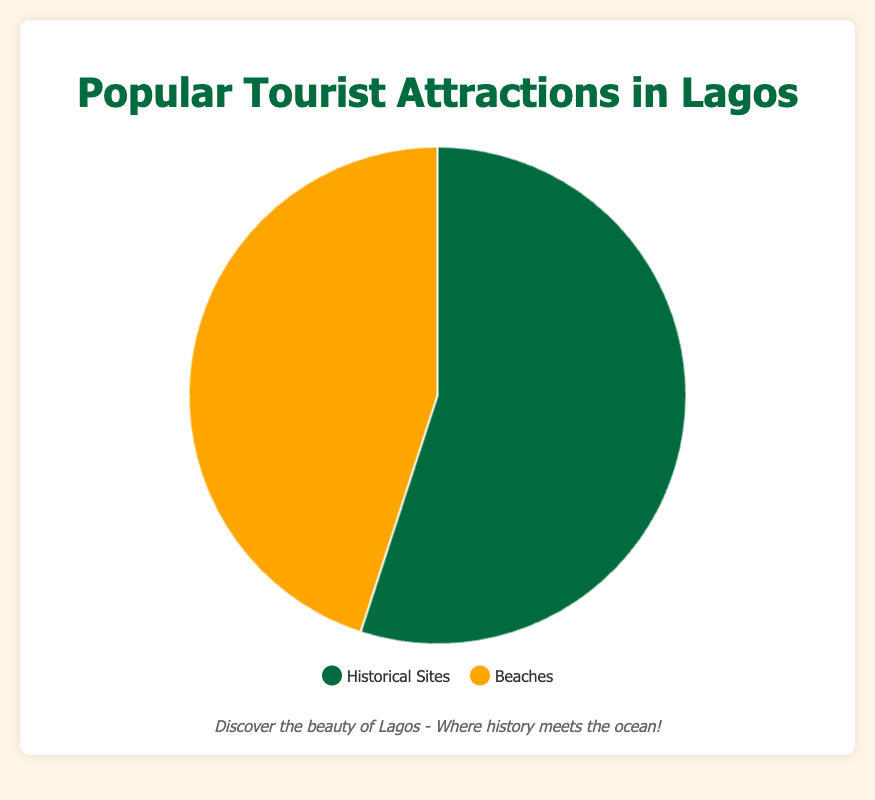What percentage of tourist attractions in Lagos are historical sites? The figure shows that historical sites make up 55% of the tourist attractions.
Answer: 55% What is the difference in percentage points between historical sites and beaches? Historical sites are at 55% and beaches at 45%, so the difference is 55 - 45 = 10 percentage points.
Answer: 10 If 20 more tourist attractions were historical sites, making the total attractions 200, what would be the new percentage of historical sites? Initially, 55% of 100 attractions are historical sites, so with 20 more, the total is 75 historical sites out of 200 attractions. The new percentage is (75/200) * 100 = 37.5%.
Answer: 37.5% Which category has a larger proportion of tourist attractions, historical sites or beaches? Historical sites have a larger proportion with 55% compared to beaches, which have 45%.
Answer: Historical Sites If the total number of tourist attractions is 1,000, how many are beaches? 45% of 1,000 attractions are beaches, so (45/100) * 1,000 = 450 beaches.
Answer: 450 If historical sites increased by 10%, what would the revised percentage be? How does it compare to the percentage of beaches? A 10% increase means moving from 55% to 55 * 1.1 = 60.5%. Compared to beaches, this would be 60.5% versus 45%.
Answer: 60.5%, greater than beaches by 15.5% What color represents historical sites in the pie chart? The pie chart uses green to represent historical sites.
Answer: Green What percentage of the total do both historical sites and beaches make up? Historical sites are 55% and beaches are 45%, summing them gives 55 + 45 = 100%.
Answer: 100% In terms of visual representation, how can you quickly identify beaches in the pie chart? Beaches are represented by the orange color in the pie chart.
Answer: Orange If both categories had an equal number of tourist attractions, what percentage would each category be? If there were an equal number, each would make up 50% of the total since the total must add up to 100%.
Answer: 50% 